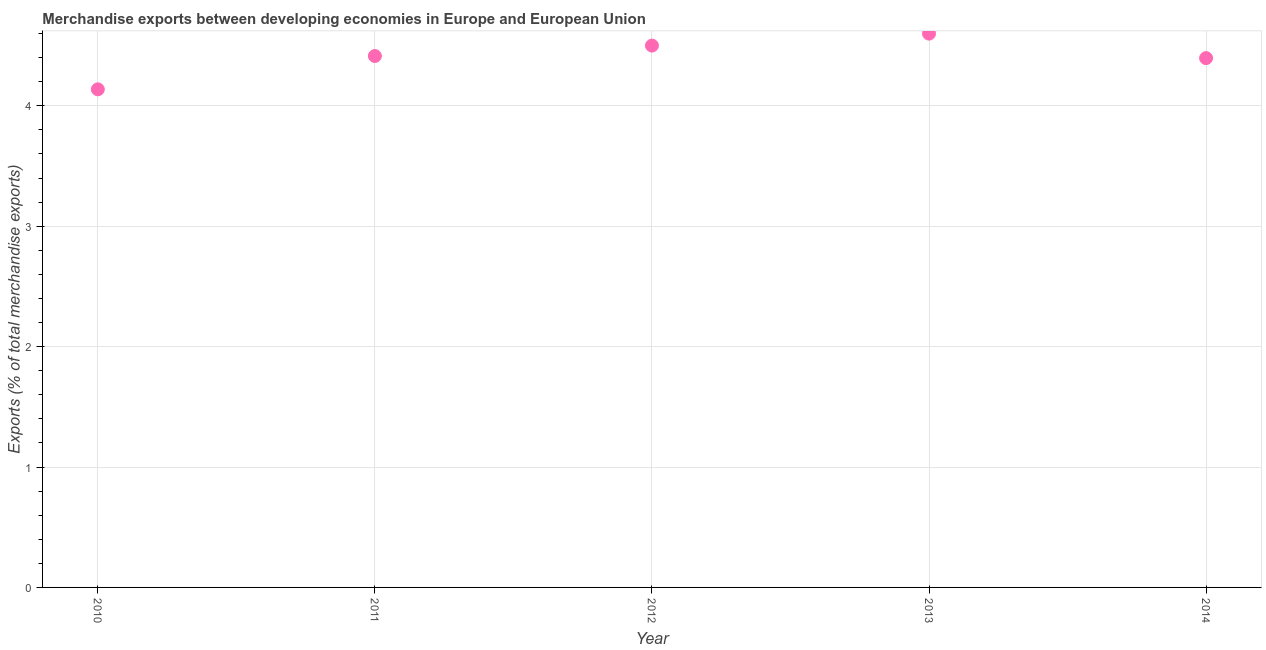What is the merchandise exports in 2013?
Offer a very short reply. 4.6. Across all years, what is the maximum merchandise exports?
Give a very brief answer. 4.6. Across all years, what is the minimum merchandise exports?
Ensure brevity in your answer.  4.14. In which year was the merchandise exports minimum?
Your answer should be compact. 2010. What is the sum of the merchandise exports?
Make the answer very short. 22.04. What is the difference between the merchandise exports in 2010 and 2014?
Provide a succinct answer. -0.26. What is the average merchandise exports per year?
Keep it short and to the point. 4.41. What is the median merchandise exports?
Ensure brevity in your answer.  4.41. In how many years, is the merchandise exports greater than 3.8 %?
Keep it short and to the point. 5. Do a majority of the years between 2013 and 2011 (inclusive) have merchandise exports greater than 3.2 %?
Give a very brief answer. No. What is the ratio of the merchandise exports in 2010 to that in 2014?
Offer a very short reply. 0.94. Is the merchandise exports in 2011 less than that in 2014?
Provide a succinct answer. No. Is the difference between the merchandise exports in 2010 and 2012 greater than the difference between any two years?
Provide a short and direct response. No. What is the difference between the highest and the second highest merchandise exports?
Your answer should be compact. 0.1. What is the difference between the highest and the lowest merchandise exports?
Your answer should be very brief. 0.46. Are the values on the major ticks of Y-axis written in scientific E-notation?
Your answer should be compact. No. Does the graph contain grids?
Make the answer very short. Yes. What is the title of the graph?
Offer a terse response. Merchandise exports between developing economies in Europe and European Union. What is the label or title of the X-axis?
Offer a very short reply. Year. What is the label or title of the Y-axis?
Your answer should be compact. Exports (% of total merchandise exports). What is the Exports (% of total merchandise exports) in 2010?
Provide a short and direct response. 4.14. What is the Exports (% of total merchandise exports) in 2011?
Offer a very short reply. 4.41. What is the Exports (% of total merchandise exports) in 2012?
Offer a terse response. 4.5. What is the Exports (% of total merchandise exports) in 2013?
Your answer should be very brief. 4.6. What is the Exports (% of total merchandise exports) in 2014?
Offer a terse response. 4.4. What is the difference between the Exports (% of total merchandise exports) in 2010 and 2011?
Ensure brevity in your answer.  -0.28. What is the difference between the Exports (% of total merchandise exports) in 2010 and 2012?
Ensure brevity in your answer.  -0.36. What is the difference between the Exports (% of total merchandise exports) in 2010 and 2013?
Provide a succinct answer. -0.46. What is the difference between the Exports (% of total merchandise exports) in 2010 and 2014?
Your answer should be compact. -0.26. What is the difference between the Exports (% of total merchandise exports) in 2011 and 2012?
Provide a short and direct response. -0.09. What is the difference between the Exports (% of total merchandise exports) in 2011 and 2013?
Ensure brevity in your answer.  -0.19. What is the difference between the Exports (% of total merchandise exports) in 2011 and 2014?
Your response must be concise. 0.02. What is the difference between the Exports (% of total merchandise exports) in 2012 and 2013?
Your response must be concise. -0.1. What is the difference between the Exports (% of total merchandise exports) in 2012 and 2014?
Your answer should be very brief. 0.1. What is the difference between the Exports (% of total merchandise exports) in 2013 and 2014?
Offer a terse response. 0.2. What is the ratio of the Exports (% of total merchandise exports) in 2010 to that in 2011?
Offer a very short reply. 0.94. What is the ratio of the Exports (% of total merchandise exports) in 2010 to that in 2012?
Keep it short and to the point. 0.92. What is the ratio of the Exports (% of total merchandise exports) in 2010 to that in 2013?
Give a very brief answer. 0.9. What is the ratio of the Exports (% of total merchandise exports) in 2010 to that in 2014?
Your answer should be very brief. 0.94. What is the ratio of the Exports (% of total merchandise exports) in 2011 to that in 2012?
Your answer should be very brief. 0.98. What is the ratio of the Exports (% of total merchandise exports) in 2011 to that in 2013?
Offer a terse response. 0.96. What is the ratio of the Exports (% of total merchandise exports) in 2013 to that in 2014?
Your answer should be very brief. 1.05. 